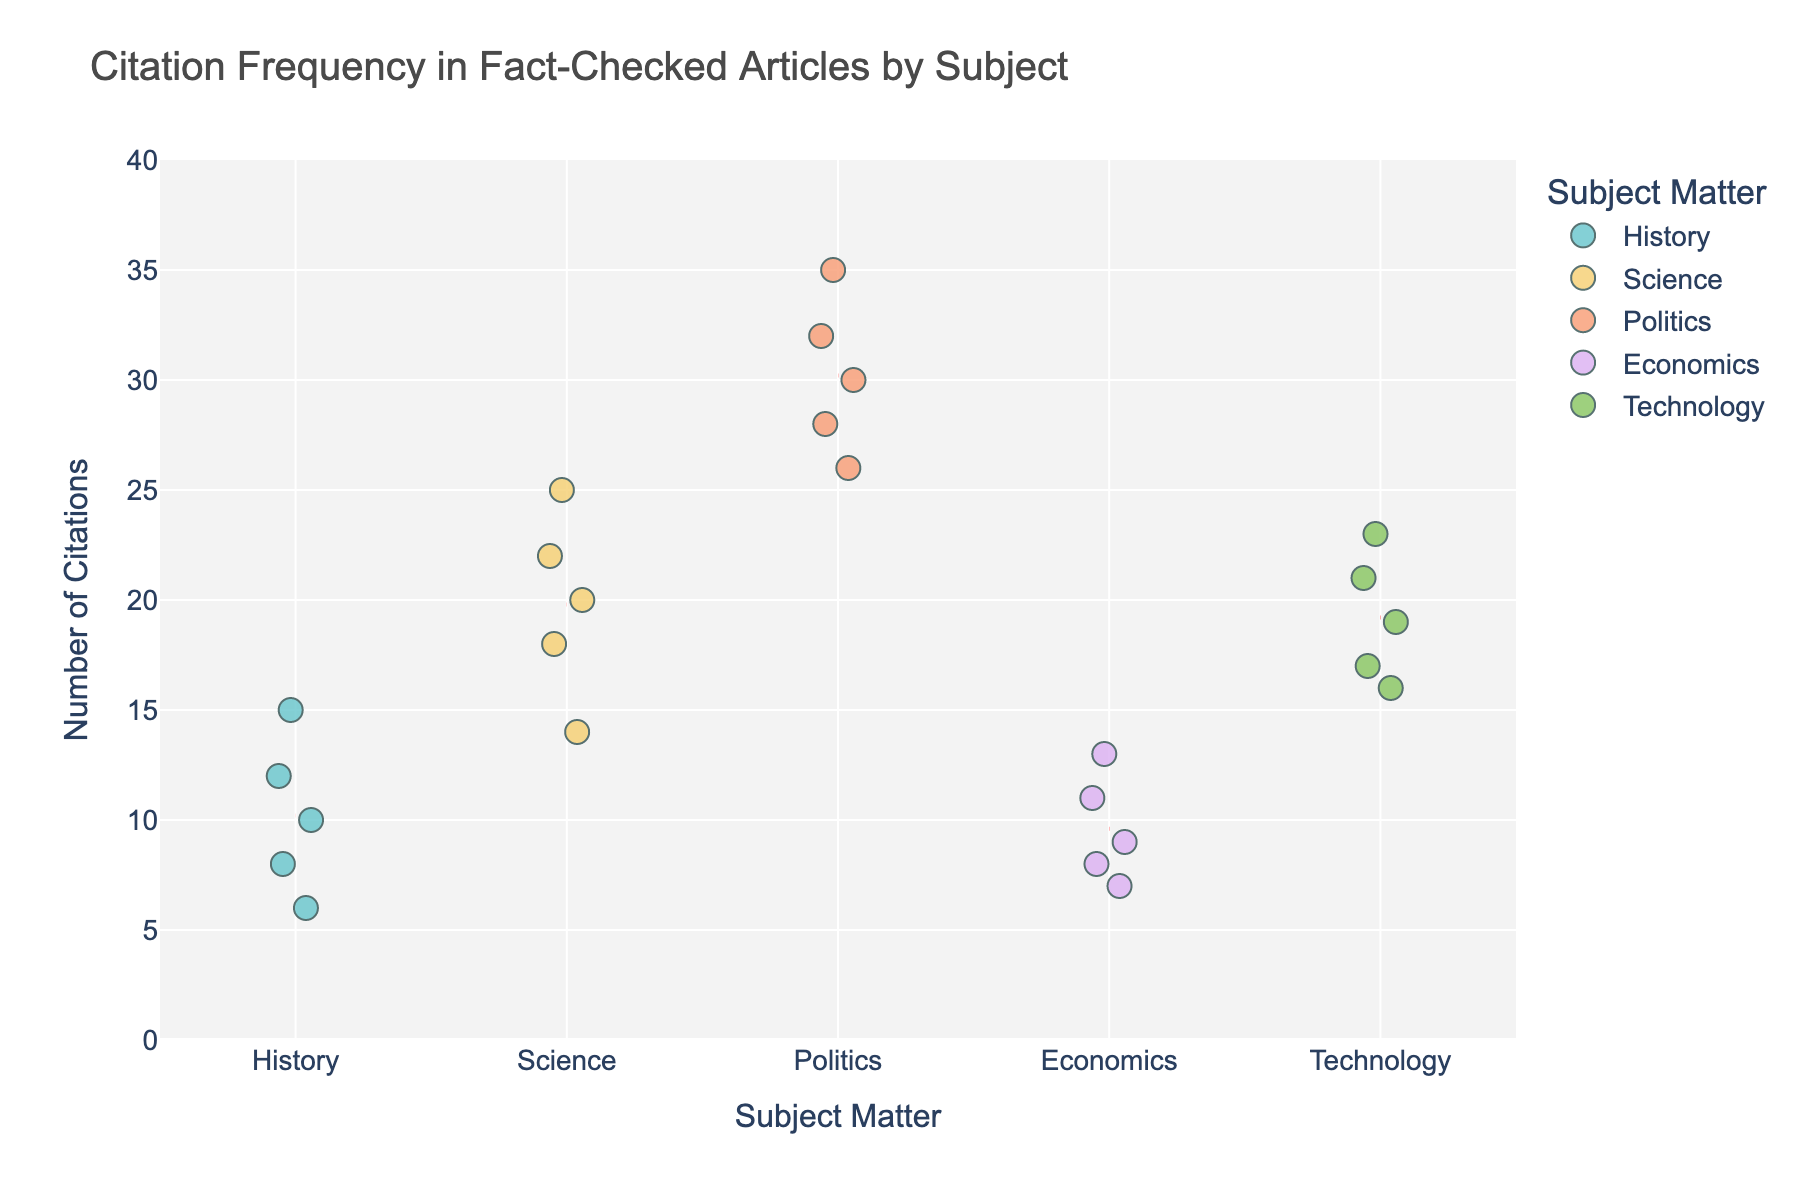What is the title of the plot? The title is displayed at the top center of the plot and reads "Citation Frequency in Fact-Checked Articles by Subject."
Answer: Citation Frequency in Fact-Checked Articles by Subject Which subject matter has the highest citation outlier in the figure? The Politics subject matter has the highest citation outlier with a value of 35, which is visibly higher than any other points.
Answer: Politics How many data points are there for the subject History? The plot shows five separate points labeled under the subject 'History', one for each data point.
Answer: 5 What's the average number of citations for the subject Technology? The average for Technology can be calculated by summing the citation values (16 + 19 + 21 + 17 + 23 = 96) and dividing by the number of points (5).
Answer: 19.2 Which subject matter has the lowest number of citations, and what is that number? The history subject matter has the lowest citation number, which is 6. This can be seen amongst the points allocated to History.
Answer: History, 6 What is the difference between the maximum citation in Science and the maximum citation in Economics? The maximum citation in Science is 25, and the maximum citation in Economics is 13. The difference is 25 - 13 = 12.
Answer: 12 Compare the range of citations (difference between the highest and lowest values) in Politics and History. For Politics, the highest citation is 35 and the lowest is 26, giving a range of 35 - 26 = 9. For History, the highest is 15 and the lowest is 6, giving a range of 15 - 6 = 9. Both have the same range.
Answer: Both are 9 What is the median number of citations for the Economics subject? The data points for Economics are {7, 8, 9, 11, 13}. The median is the middle value, which is 9.
Answer: 9 Which subject has the smallest variance in the number of citations? By visually inspecting the spread of data points, the Economics subject appears to have the smallest variance since the citations are clustered closely together.
Answer: Economics 